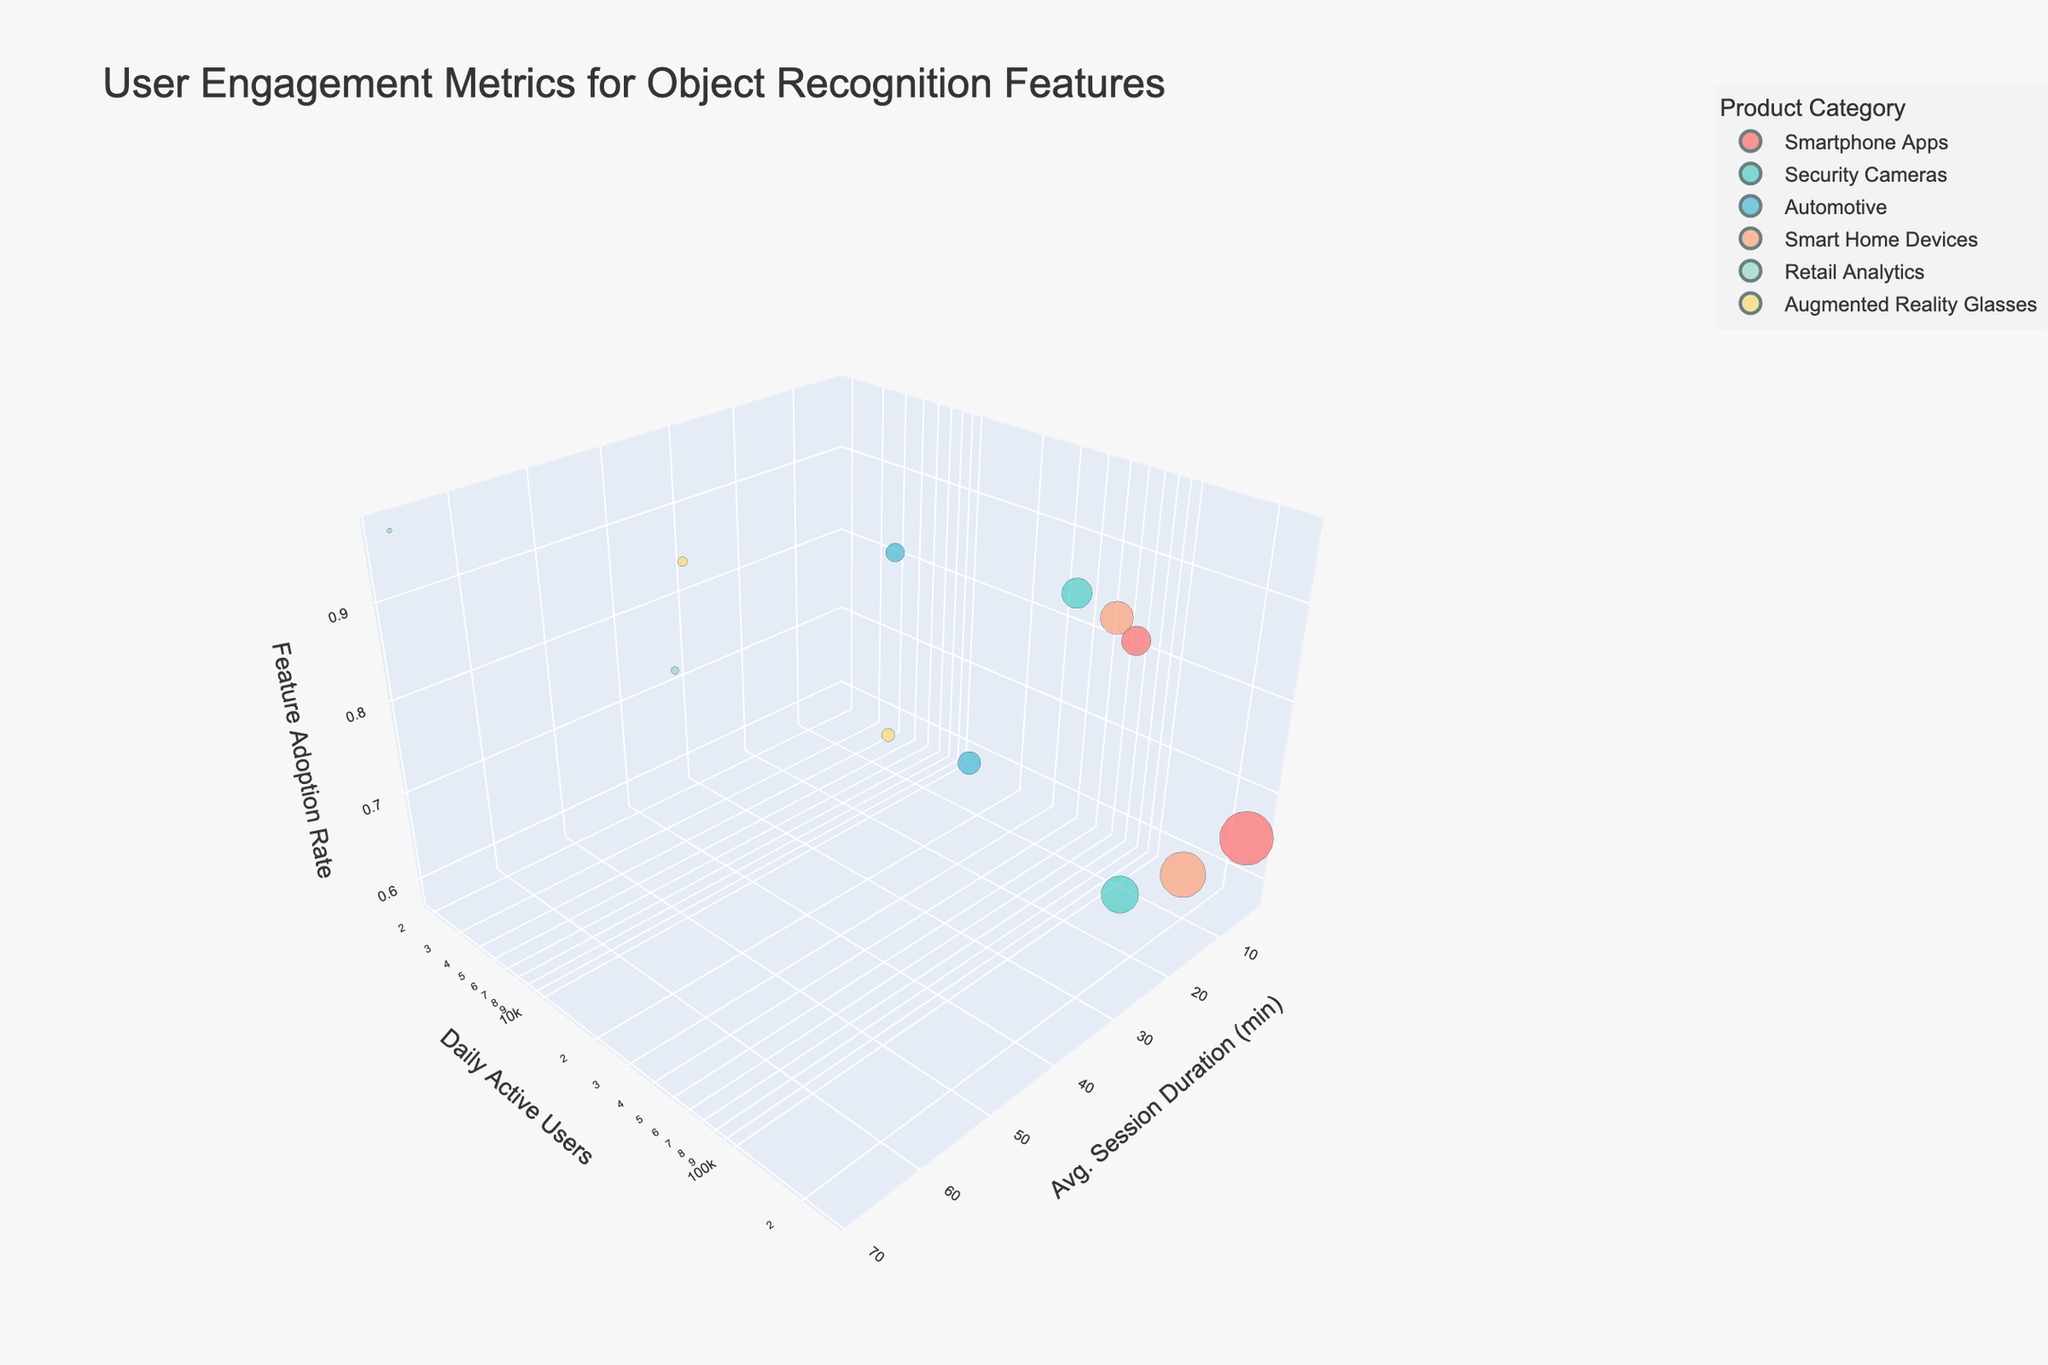What is the title of the plot? The title is located at the top center of the plot. It indicates the main subject of the visualization, which in this case is "User Engagement Metrics for Object Recognition Features."
Answer: User Engagement Metrics for Object Recognition Features Which product category has the highest feature adoption rate? Looking at the z-axis, which represents the feature adoption rate, the highest bubble point on this axis corresponds to the 'Retail Analytics - Enterprise' category.
Answer: Retail Analytics - Enterprise How many product categories are represented in the plot? The legend on the right side of the plot lists all the distinct product categories used to color the bubbles. Counting these categories gives us the number of product categories.
Answer: Six Which product category has the largest daily active user base and what is its average session duration? The size of the bubbles represents the daily active users. The largest bubble is for 'Smartphone Apps (Free)', and the y-axis value for this bubble represents its average session duration.
Answer: Smartphone Apps (Free), 3.5 minutes Compare the feature adoption rate between 'Automotive - Mid-range' and 'Security Cameras - Budget.' Which one is higher? Locate both points on the z-axis to compare their heights. 'Automotive - Mid-range' has a higher feature adoption rate than 'Security Cameras - Budget.'
Answer: Automotive - Mid-range Which product category-price combination has the longest average session duration, and how long is it? By examining the x-axis for the maximum value, the 'Retail Analytics - Enterprise' category has the longest average session duration.
Answer: Retail Analytics - Enterprise, 68.3 minutes What is the daily active user difference between 'Smart Home Devices - Entry-level' and 'Security Cameras - Premium'? Find the bubble sizes (which correspond to daily active users) for both categories and subtract the smaller value from the larger one (180,000 - 80,000).
Answer: 100,000 users Which product category has the smallest bubble size and what does it represent? The smallest bubble on the plot is 'Retail Analytics - Enterprise,' representing the smallest number of daily active users.
Answer: Retail Analytics - Enterprise 